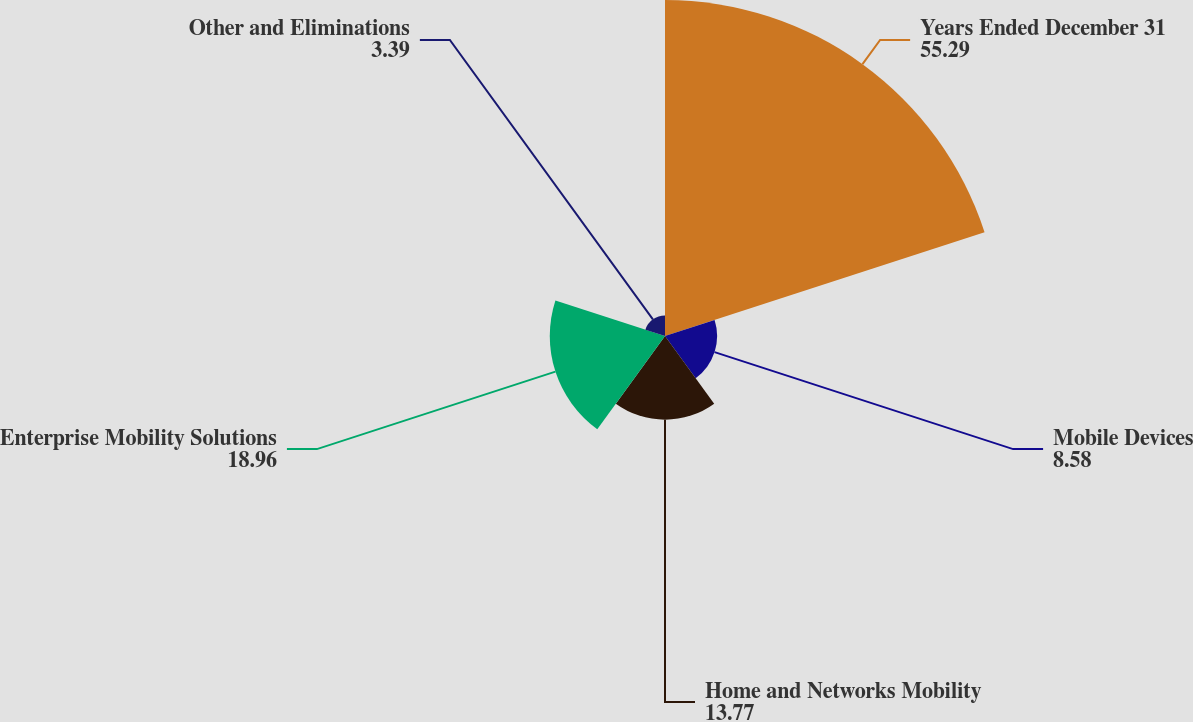Convert chart. <chart><loc_0><loc_0><loc_500><loc_500><pie_chart><fcel>Years Ended December 31<fcel>Mobile Devices<fcel>Home and Networks Mobility<fcel>Enterprise Mobility Solutions<fcel>Other and Eliminations<nl><fcel>55.29%<fcel>8.58%<fcel>13.77%<fcel>18.96%<fcel>3.39%<nl></chart> 